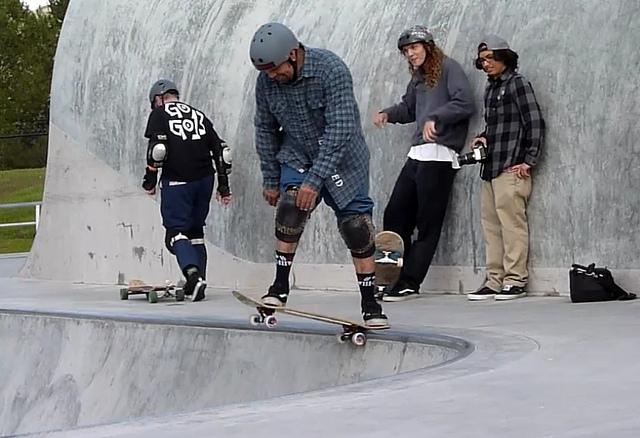Besides his head what part of his body is the skateboarder on the edge of the ramp protecting?

Choices:
A) shoulders
B) wrists
C) knees
D) elbows knees 